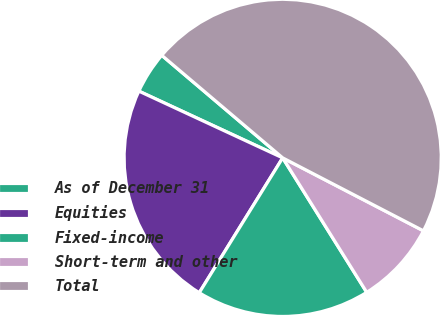<chart> <loc_0><loc_0><loc_500><loc_500><pie_chart><fcel>As of December 31<fcel>Equities<fcel>Fixed-income<fcel>Short-term and other<fcel>Total<nl><fcel>4.28%<fcel>23.1%<fcel>17.71%<fcel>8.5%<fcel>46.42%<nl></chart> 